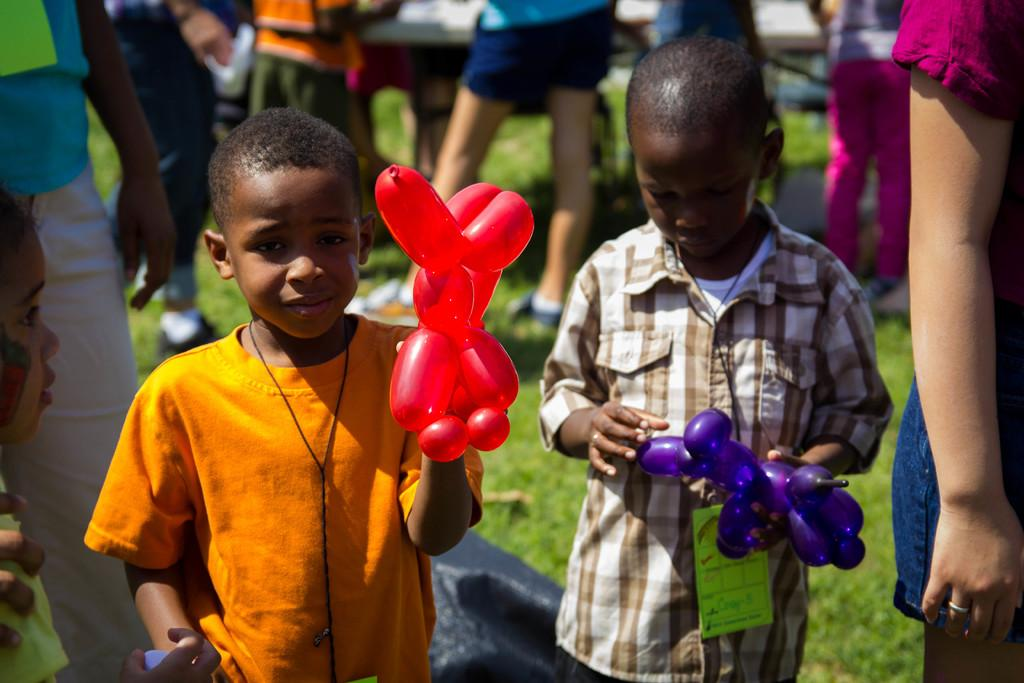Who can be seen in the image? There are people in the image. What are the kids holding in the image? Two kids are holding balloons. What type of surface is visible in the image? There is grass visible in the image. Can you describe the background of the image? The background of the image is blurred. What type of reaction can be seen from the writer in the image? There is no writer present in the image, so it is not possible to determine any reactions from a writer. 